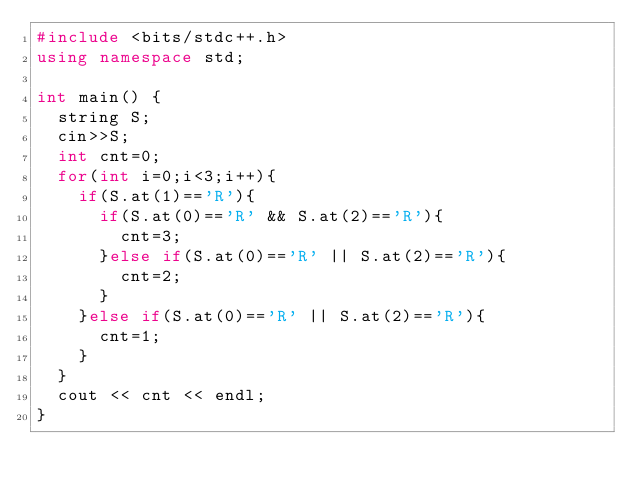Convert code to text. <code><loc_0><loc_0><loc_500><loc_500><_C++_>#include <bits/stdc++.h>
using namespace std;

int main() {
  string S;
  cin>>S;
  int cnt=0;
  for(int i=0;i<3;i++){
    if(S.at(1)=='R'){
      if(S.at(0)=='R' && S.at(2)=='R'){
      	cnt=3;
      }else if(S.at(0)=='R' || S.at(2)=='R'){
        cnt=2;
      }
    }else if(S.at(0)=='R' || S.at(2)=='R'){
      cnt=1;
    }
  }
  cout << cnt << endl;
}

</code> 